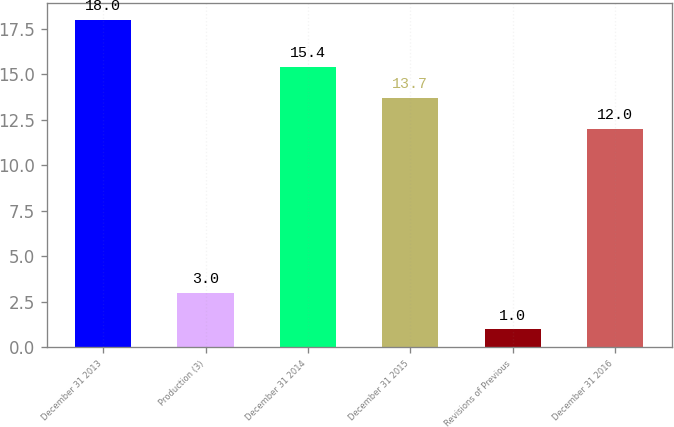Convert chart. <chart><loc_0><loc_0><loc_500><loc_500><bar_chart><fcel>December 31 2013<fcel>Production (3)<fcel>December 31 2014<fcel>December 31 2015<fcel>Revisions of Previous<fcel>December 31 2016<nl><fcel>18<fcel>3<fcel>15.4<fcel>13.7<fcel>1<fcel>12<nl></chart> 